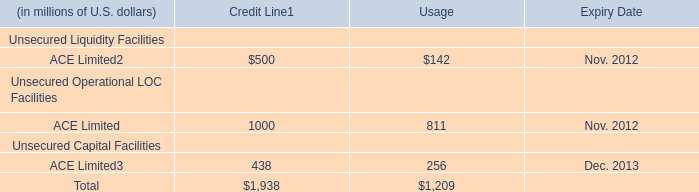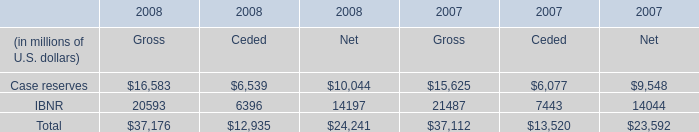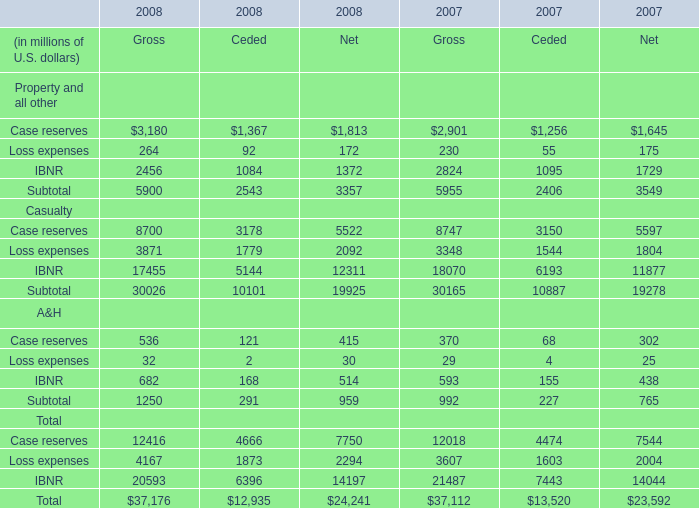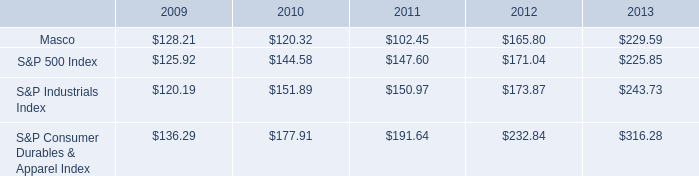what was the percentage cumulative total shareholder return on masco common stock for the five year period ended 2013? 
Computations: ((229.59 - 100) / 100)
Answer: 1.2959. 